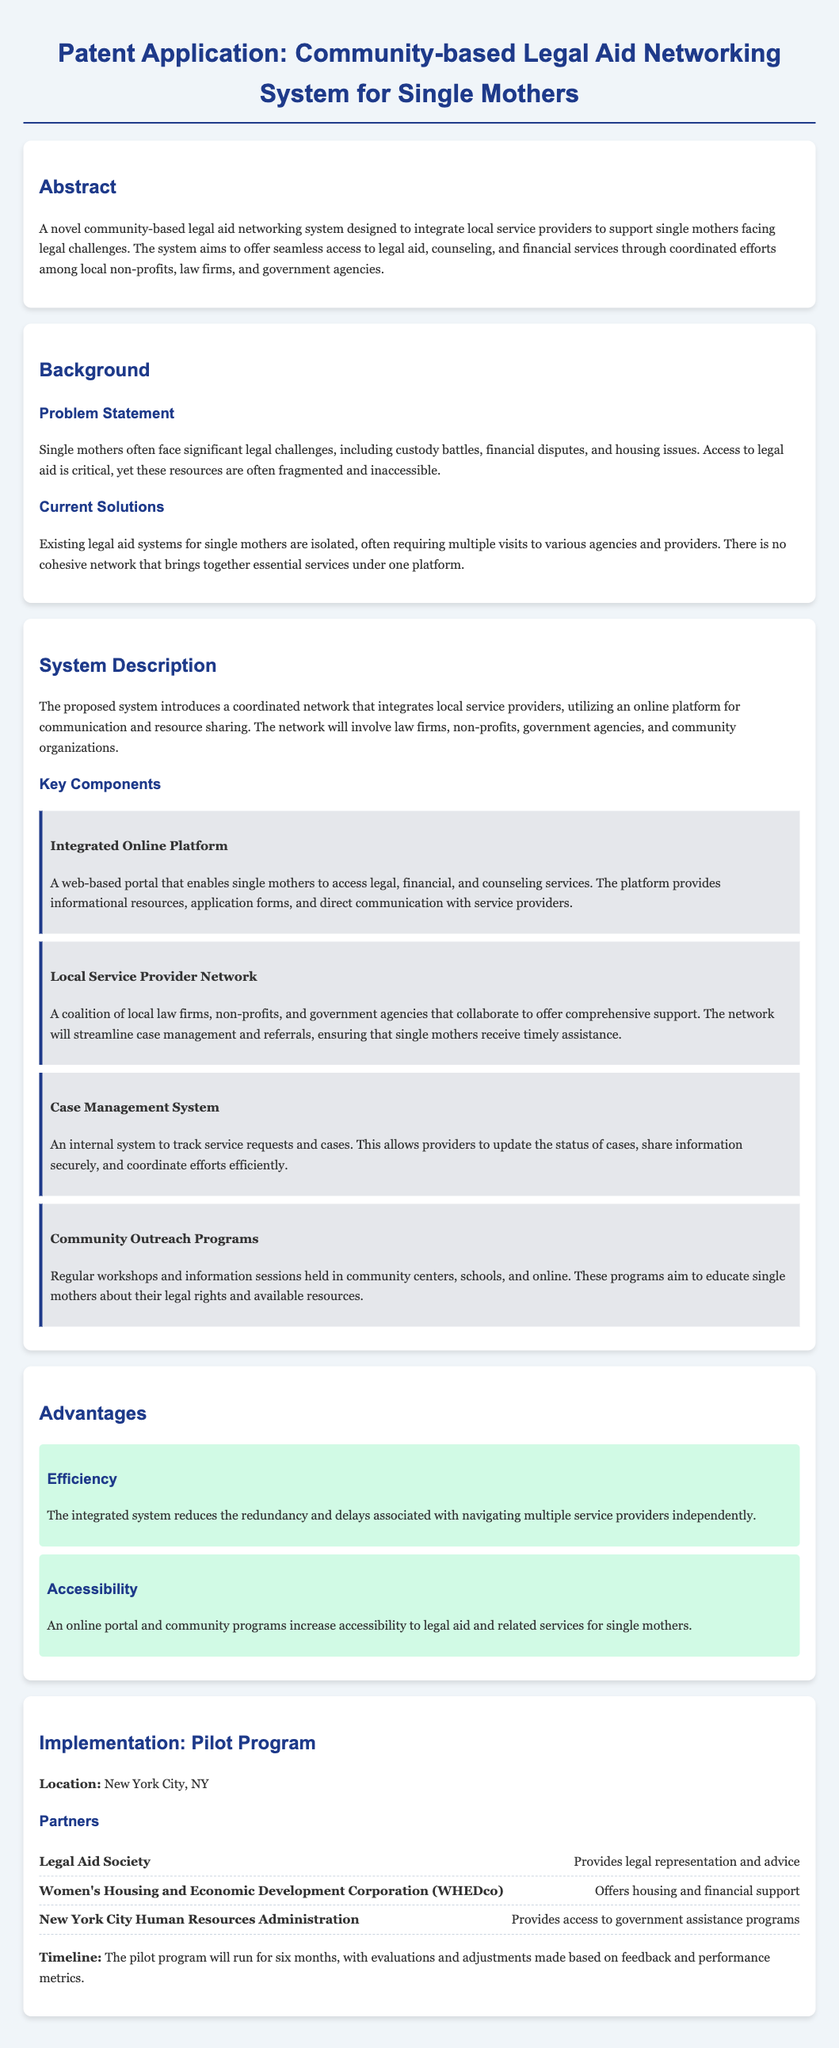what is the title of the patent application? The title provides the specific name of the patent application document.
Answer: Community-based Legal Aid Networking System for Single Mothers what is the main problem addressed by the system? The main problem statement outlines the specific issues single mothers face regarding access to legal aid.
Answer: Significant legal challenges what is one key component of the proposed system? The document lists various components that make up the proposed system.
Answer: Integrated Online Platform who is one of the partners in the pilot program? The listing of partners in the pilot program provides details on collaborators involved.
Answer: Legal Aid Society what is the duration of the pilot program? The timeline for the implementation of the pilot program gives its planned duration.
Answer: Six months what type of outreach programs are included in the system description? The outreach initiatives are mentioned as part of the community engagement strategy.
Answer: Community Outreach Programs list one advantage of the community-based legal aid system. The advantages section highlights benefits derived from the proposed system.
Answer: Accessibility how many local service providers are involved in the network? The description of the service provider network explains the collaboration effort but does not specify a number.
Answer: Not specified 